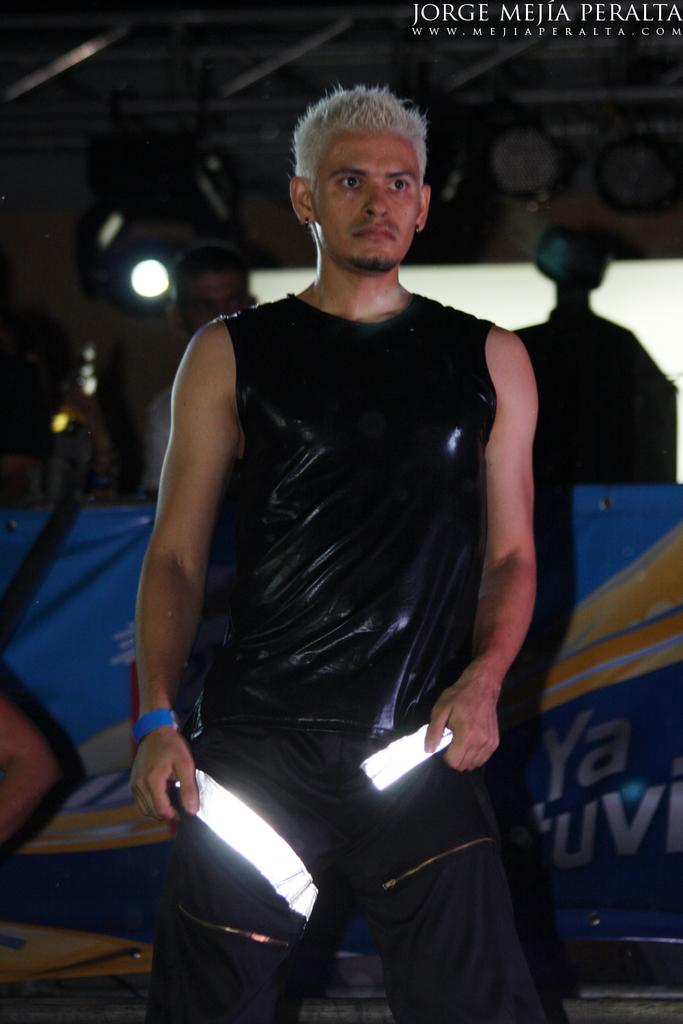Provide a one-sentence caption for the provided image. A man dressed in black and holding blades poses in this Jorge Mejia Peralta photo. 